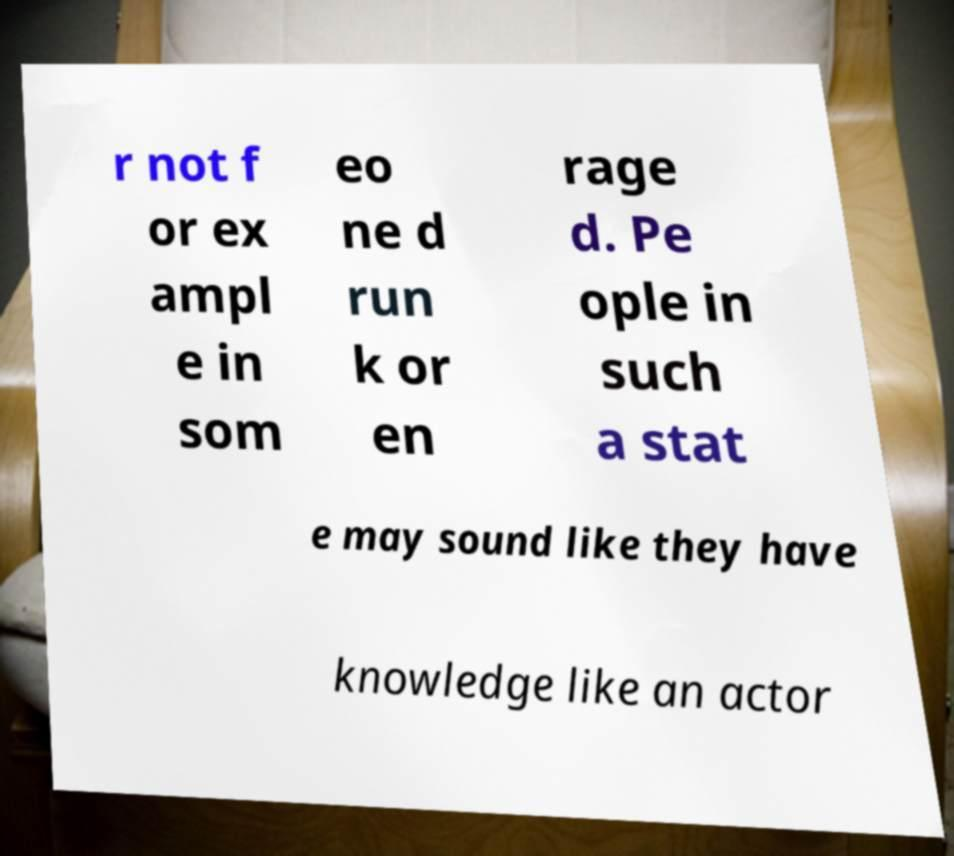I need the written content from this picture converted into text. Can you do that? r not f or ex ampl e in som eo ne d run k or en rage d. Pe ople in such a stat e may sound like they have knowledge like an actor 